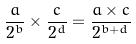<formula> <loc_0><loc_0><loc_500><loc_500>\frac { a } { 2 ^ { b } } \times \frac { c } { 2 ^ { d } } = \frac { a \times c } { 2 ^ { b + d } }</formula> 